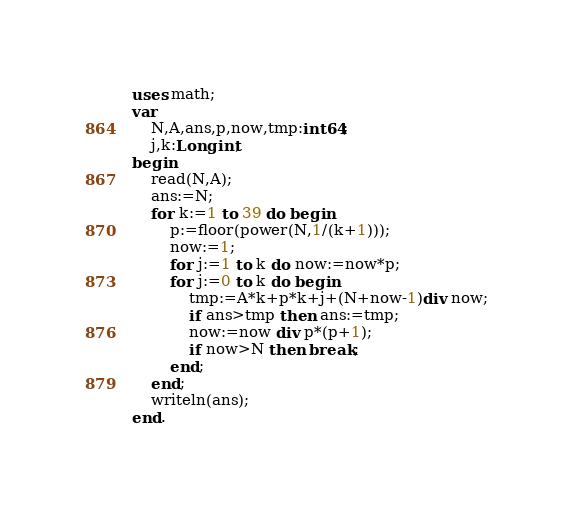Convert code to text. <code><loc_0><loc_0><loc_500><loc_500><_Pascal_>uses math;
var
	N,A,ans,p,now,tmp:int64;
	j,k:Longint;
begin
	read(N,A);
	ans:=N;
	for k:=1 to 39 do begin
		p:=floor(power(N,1/(k+1)));
		now:=1;
		for j:=1 to k do now:=now*p;
		for j:=0 to k do begin
			tmp:=A*k+p*k+j+(N+now-1)div now;
			if ans>tmp then ans:=tmp;
			now:=now div p*(p+1);
			if now>N then break;
		end;
	end;
	writeln(ans);
end.</code> 